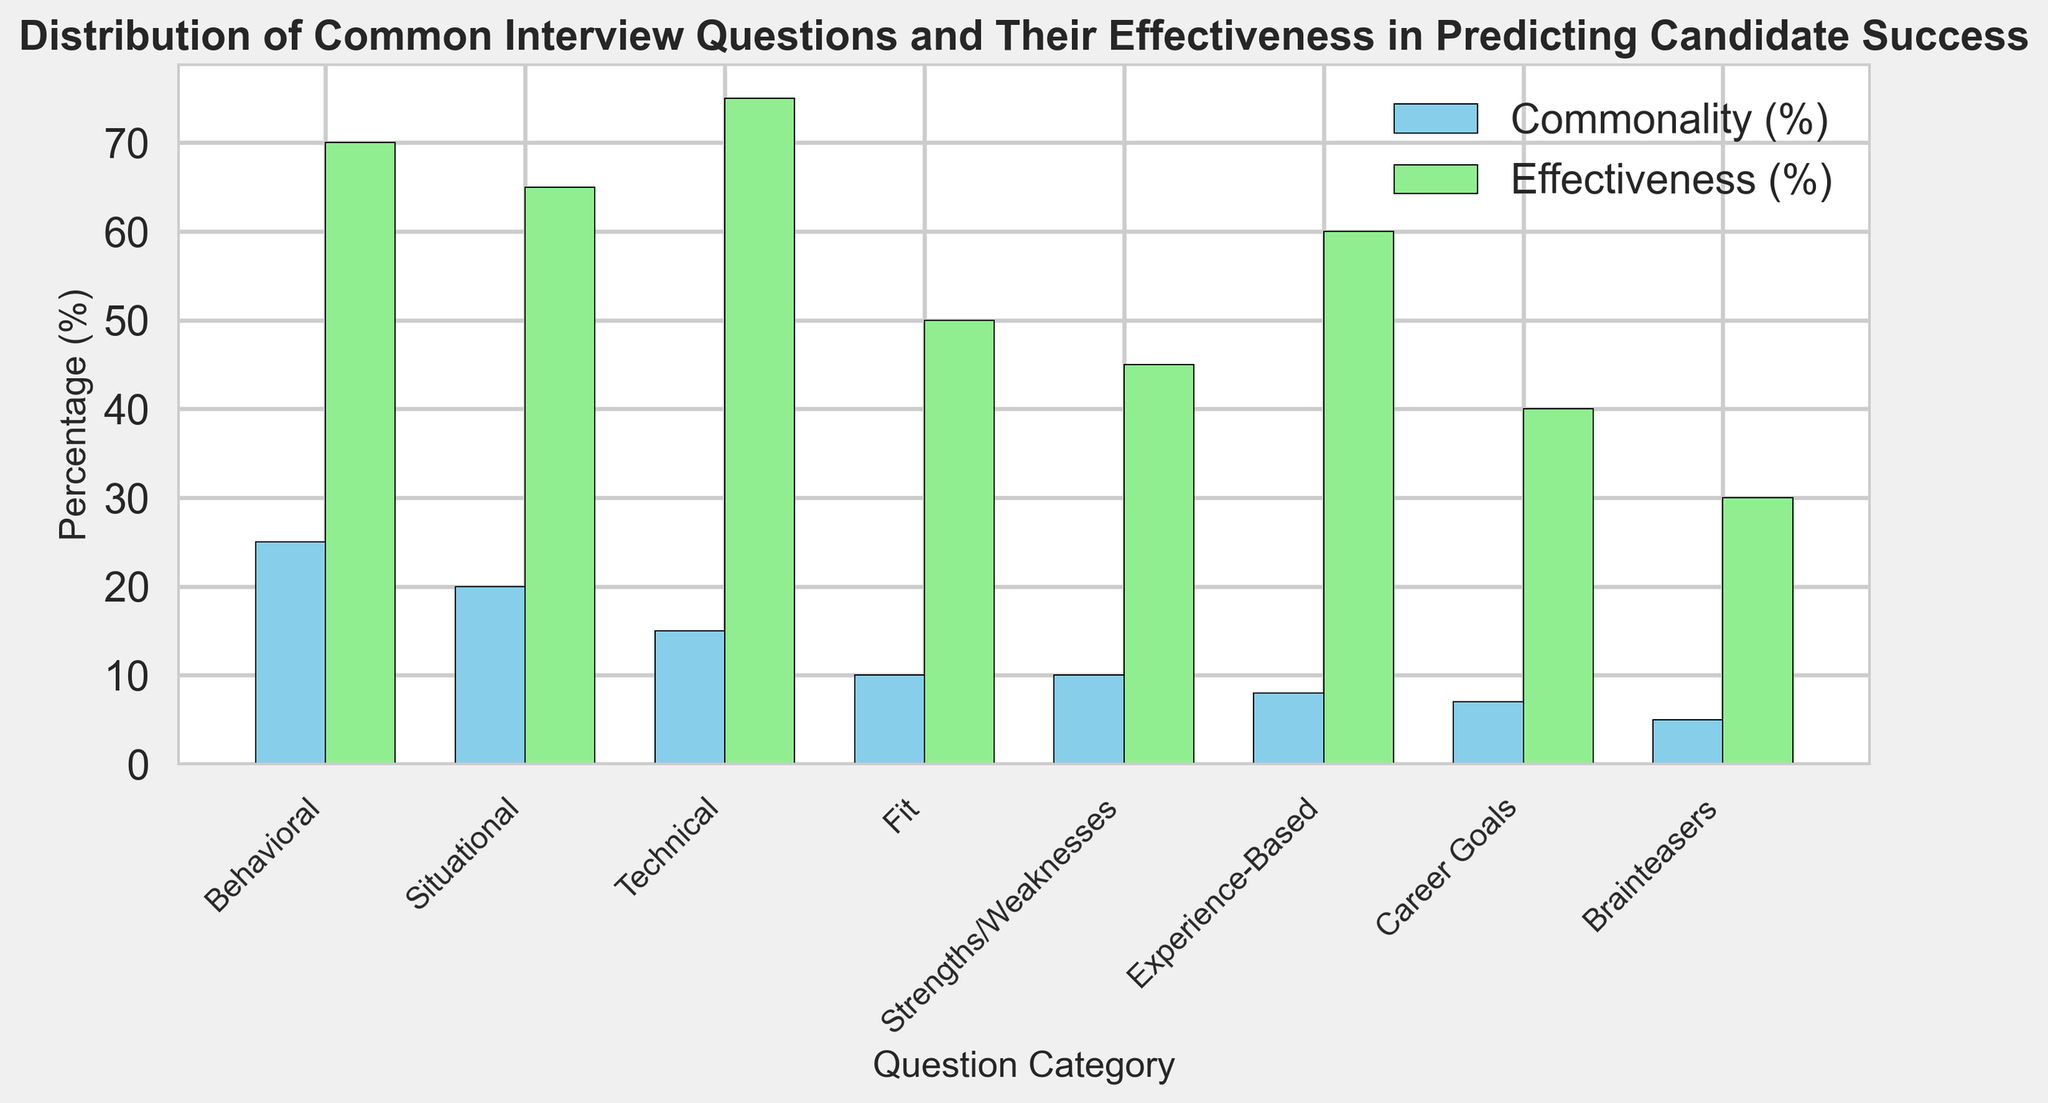What category has the highest effectiveness? The bar chart shows the effectiveness of different interview question categories. The "Technical" category has the tallest light green bar, indicating it has the highest effectiveness.
Answer: Technical Which question type has both commonality and effectiveness above 60%? By looking at both sets of bars, we see that the "Behavioral" category has commonality at 25% and effectiveness at 70%. These values are both above 60%.
Answer: Behavioral What is the difference in effectiveness between 'Behavioral' and 'Fit' questions? The effectiveness of 'Behavioral' questions is 70%, and 'Fit' questions is 50%. The difference is 70% - 50% = 20%.
Answer: 20% Which category has the least commonality? The bar chart shows the commonality of different interview question categories. The category with the shortest light blue bar is "Brainteasers," indicating it has the least commonality.
Answer: Brainteasers How does the commonality of 'Situational' questions compare to 'Technical' questions? The 'Situational' questions have a commonality of 20%, while the 'Technical' questions have a commonality of 15%. Comparing these values, 'Situational' questions have a higher commonality.
Answer: 'Situational' is higher Which two categories have an effectiveness of less than 50%? By reviewing the effectiveness bars, 'Strengths/Weaknesses' at 45% and 'Brainteasers' at 30% are less than 50%.
Answer: Strengths/Weaknesses, Brainteasers What is the average commonality percentage of 'Experience-Based' and 'Career Goals' questions? The commonality of 'Experience-Based' questions is 8% and 'Career Goals' questions is 7%. The average is calculated as (8% + 7%) / 2 = 7.5%.
Answer: 7.5% Visualize and describe the effectiveness trend from 'Behavioral' to 'Brainteasers'? As we move from 'Behavioral' to 'Brainteasers', the light green effectiveness bars decrease: 'Behavioral' (70%), 'Situational' (65%), 'Technical' (75%), 'Fit' (50%), 'Strengths/Weaknesses' (45%), 'Experience-Based' (60%), 'Career Goals' (40%), 'Brainteasers' (30%). Therefore, the general trend is a decrease in effectiveness except for a spike in 'Technical'.
Answer: General decrease with a spike Is there a direct correlation between commonality and effectiveness of 'Strengths/Weaknesses' questions? The commonality is 10% and the effectiveness is 45% for 'Strengths/Weaknesses' questions. The values don’t suggest a direct correlation since low commonality doesn’t correspond to high effectiveness.
Answer: No direct correlation 